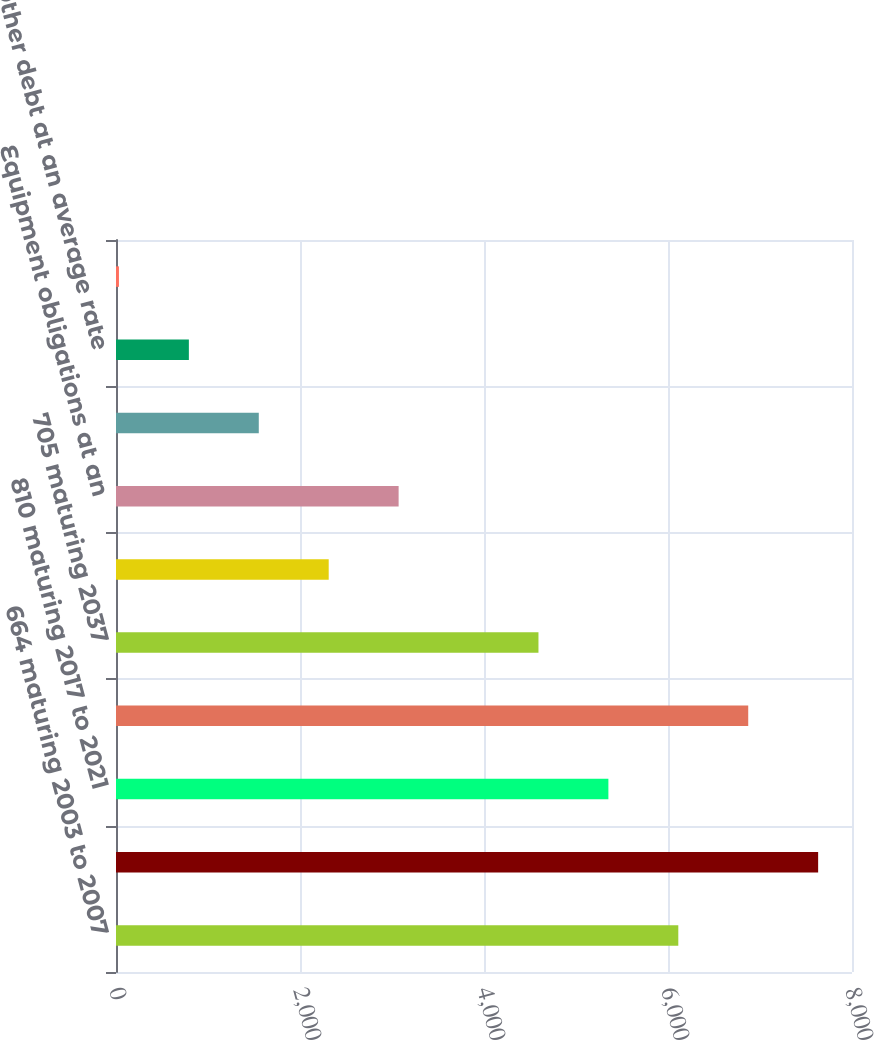Convert chart to OTSL. <chart><loc_0><loc_0><loc_500><loc_500><bar_chart><fcel>664 maturing 2003 to 2007<fcel>691 maturing 2008 to 2011<fcel>810 maturing 2017 to 2021<fcel>754 maturing 2027 to 2031<fcel>705 maturing 2037<fcel>790 maturing 2097<fcel>Equipment obligations at an<fcel>Capitalized leases at an<fcel>Other debt at an average rate<fcel>Discounts and premiums net<nl><fcel>6112<fcel>7632<fcel>5352<fcel>6872<fcel>4592<fcel>2312<fcel>3072<fcel>1552<fcel>792<fcel>32<nl></chart> 